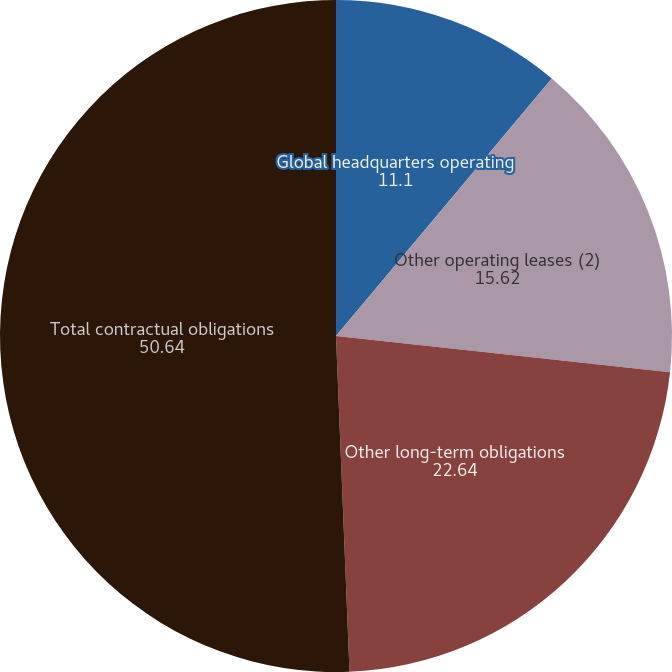<chart> <loc_0><loc_0><loc_500><loc_500><pie_chart><fcel>Global headquarters operating<fcel>Other operating leases (2)<fcel>Other long-term obligations<fcel>Total contractual obligations<nl><fcel>11.1%<fcel>15.62%<fcel>22.64%<fcel>50.64%<nl></chart> 